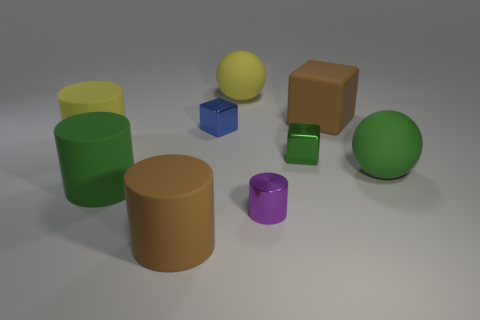There is a brown thing that is to the left of the rubber block; does it have the same size as the purple metallic cylinder?
Make the answer very short. No. How many big yellow rubber objects are to the left of the tiny blue thing?
Provide a succinct answer. 1. Are there any brown rubber blocks of the same size as the green shiny cube?
Your answer should be compact. No. Do the rubber cube and the tiny metal cylinder have the same color?
Your response must be concise. No. What color is the ball that is behind the large yellow rubber cylinder left of the brown matte cylinder?
Offer a very short reply. Yellow. What number of matte objects are both to the right of the small cylinder and to the left of the green cylinder?
Your answer should be very brief. 0. How many tiny green shiny things have the same shape as the small purple thing?
Your answer should be very brief. 0. Is the large green cylinder made of the same material as the big green sphere?
Your response must be concise. Yes. There is a big yellow rubber object that is to the right of the big green matte object that is in front of the green sphere; what shape is it?
Your response must be concise. Sphere. There is a tiny purple cylinder that is in front of the yellow matte sphere; how many purple cylinders are behind it?
Your response must be concise. 0. 